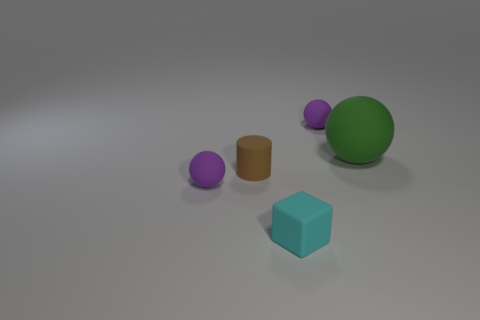Subtract all small purple balls. How many balls are left? 1 Subtract all purple spheres. How many spheres are left? 1 Add 3 small brown objects. How many objects exist? 8 Subtract all spheres. How many objects are left? 2 Subtract all yellow blocks. How many purple spheres are left? 2 Add 2 small cyan things. How many small cyan things are left? 3 Add 5 big red shiny blocks. How many big red shiny blocks exist? 5 Subtract 0 gray spheres. How many objects are left? 5 Subtract 1 blocks. How many blocks are left? 0 Subtract all cyan balls. Subtract all cyan cubes. How many balls are left? 3 